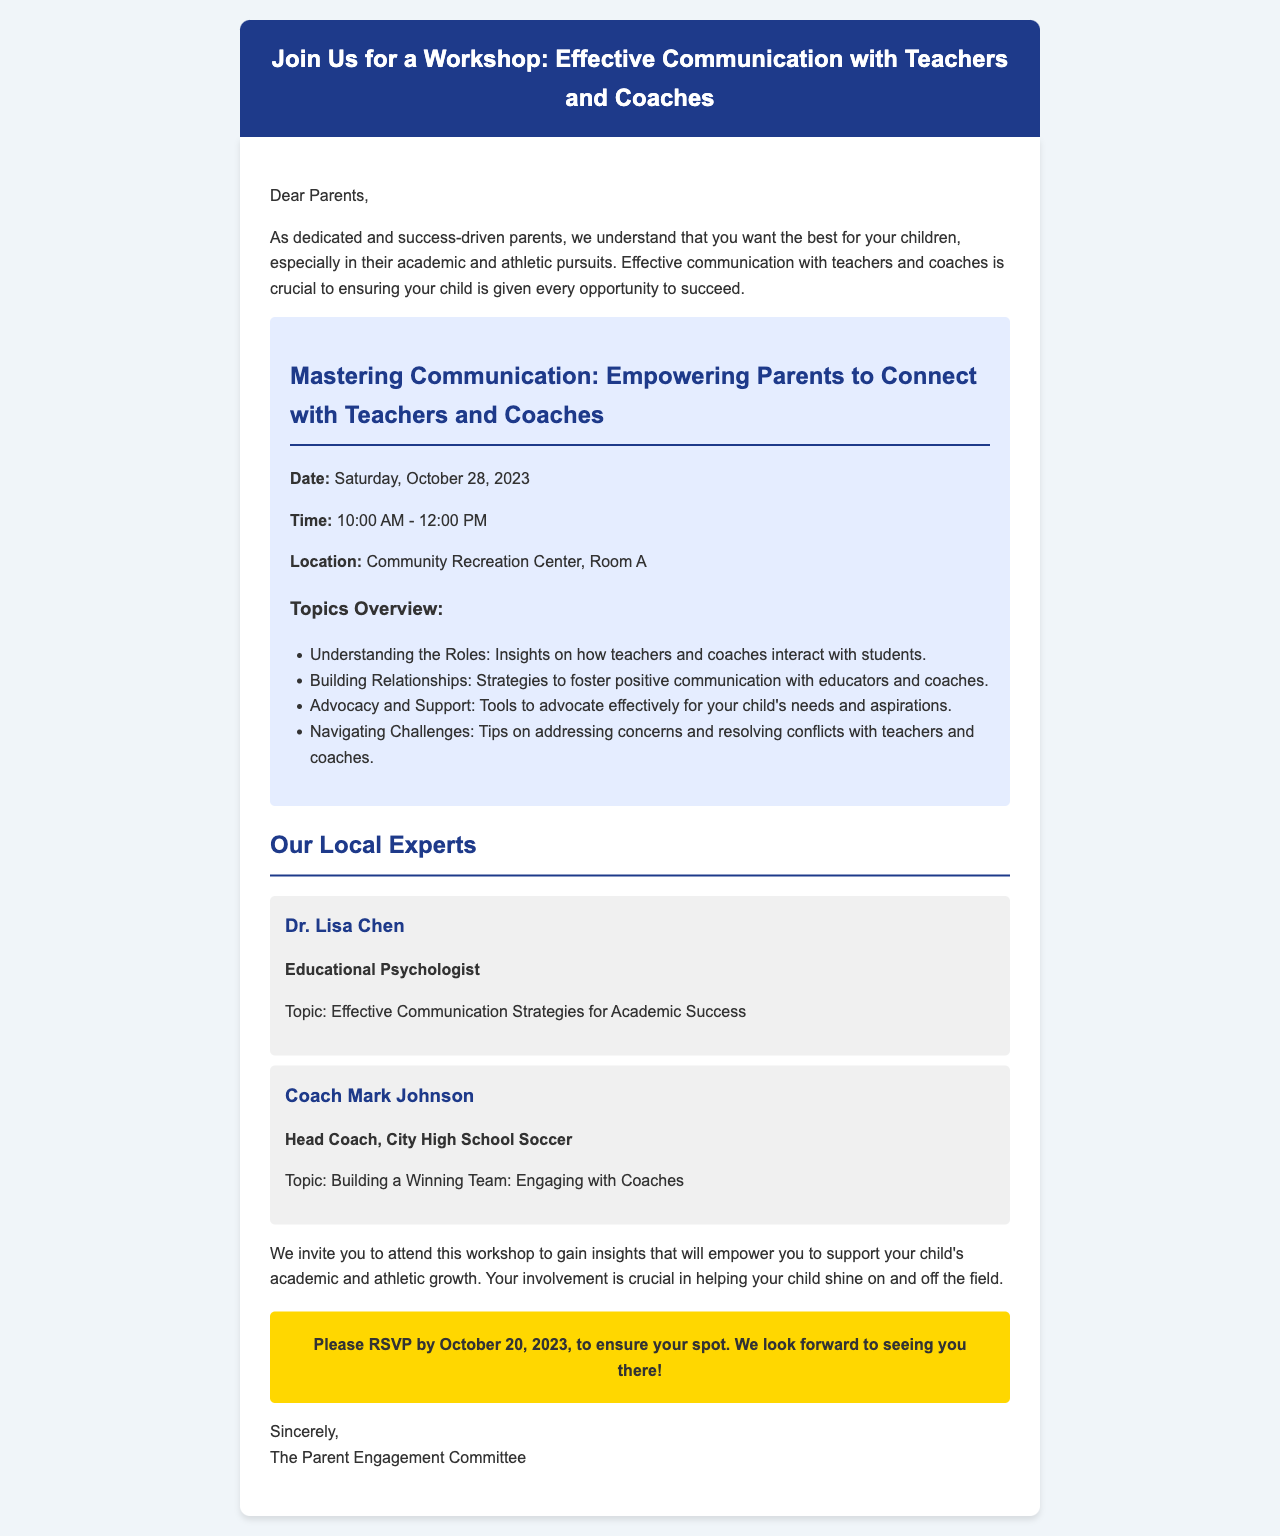What is the date of the workshop? The date of the workshop is specifically mentioned in the document.
Answer: Saturday, October 28, 2023 What time does the workshop start? The start time of the workshop is clearly listed in the document.
Answer: 10:00 AM Where is the workshop located? The location of the workshop is detailed in the content section of the document.
Answer: Community Recreation Center, Room A Who is the educational psychologist mentioned in the document? The document provides the name and title of the expert.
Answer: Dr. Lisa Chen What is one of the topics covered in the workshop? The document lists several topics as part of the workshop agenda.
Answer: Understanding the Roles Why is attending the workshop important for parents? The document emphasizes the significance of parent involvement regarding their children's success.
Answer: Support your child's academic and athletic growth When is the RSVP deadline? The deadline for RSVPing is explicitly stated in the workshop invitation.
Answer: October 20, 2023 What is the title of Coach Mark Johnson? The document mentions the title of the coach as part of his introduction.
Answer: Head Coach, City High School Soccer What type of strategies will Dr. Lisa Chen discuss? The document specifies the type of strategies related to Dr. Lisa Chen's topic.
Answer: Effective Communication Strategies for Academic Success 